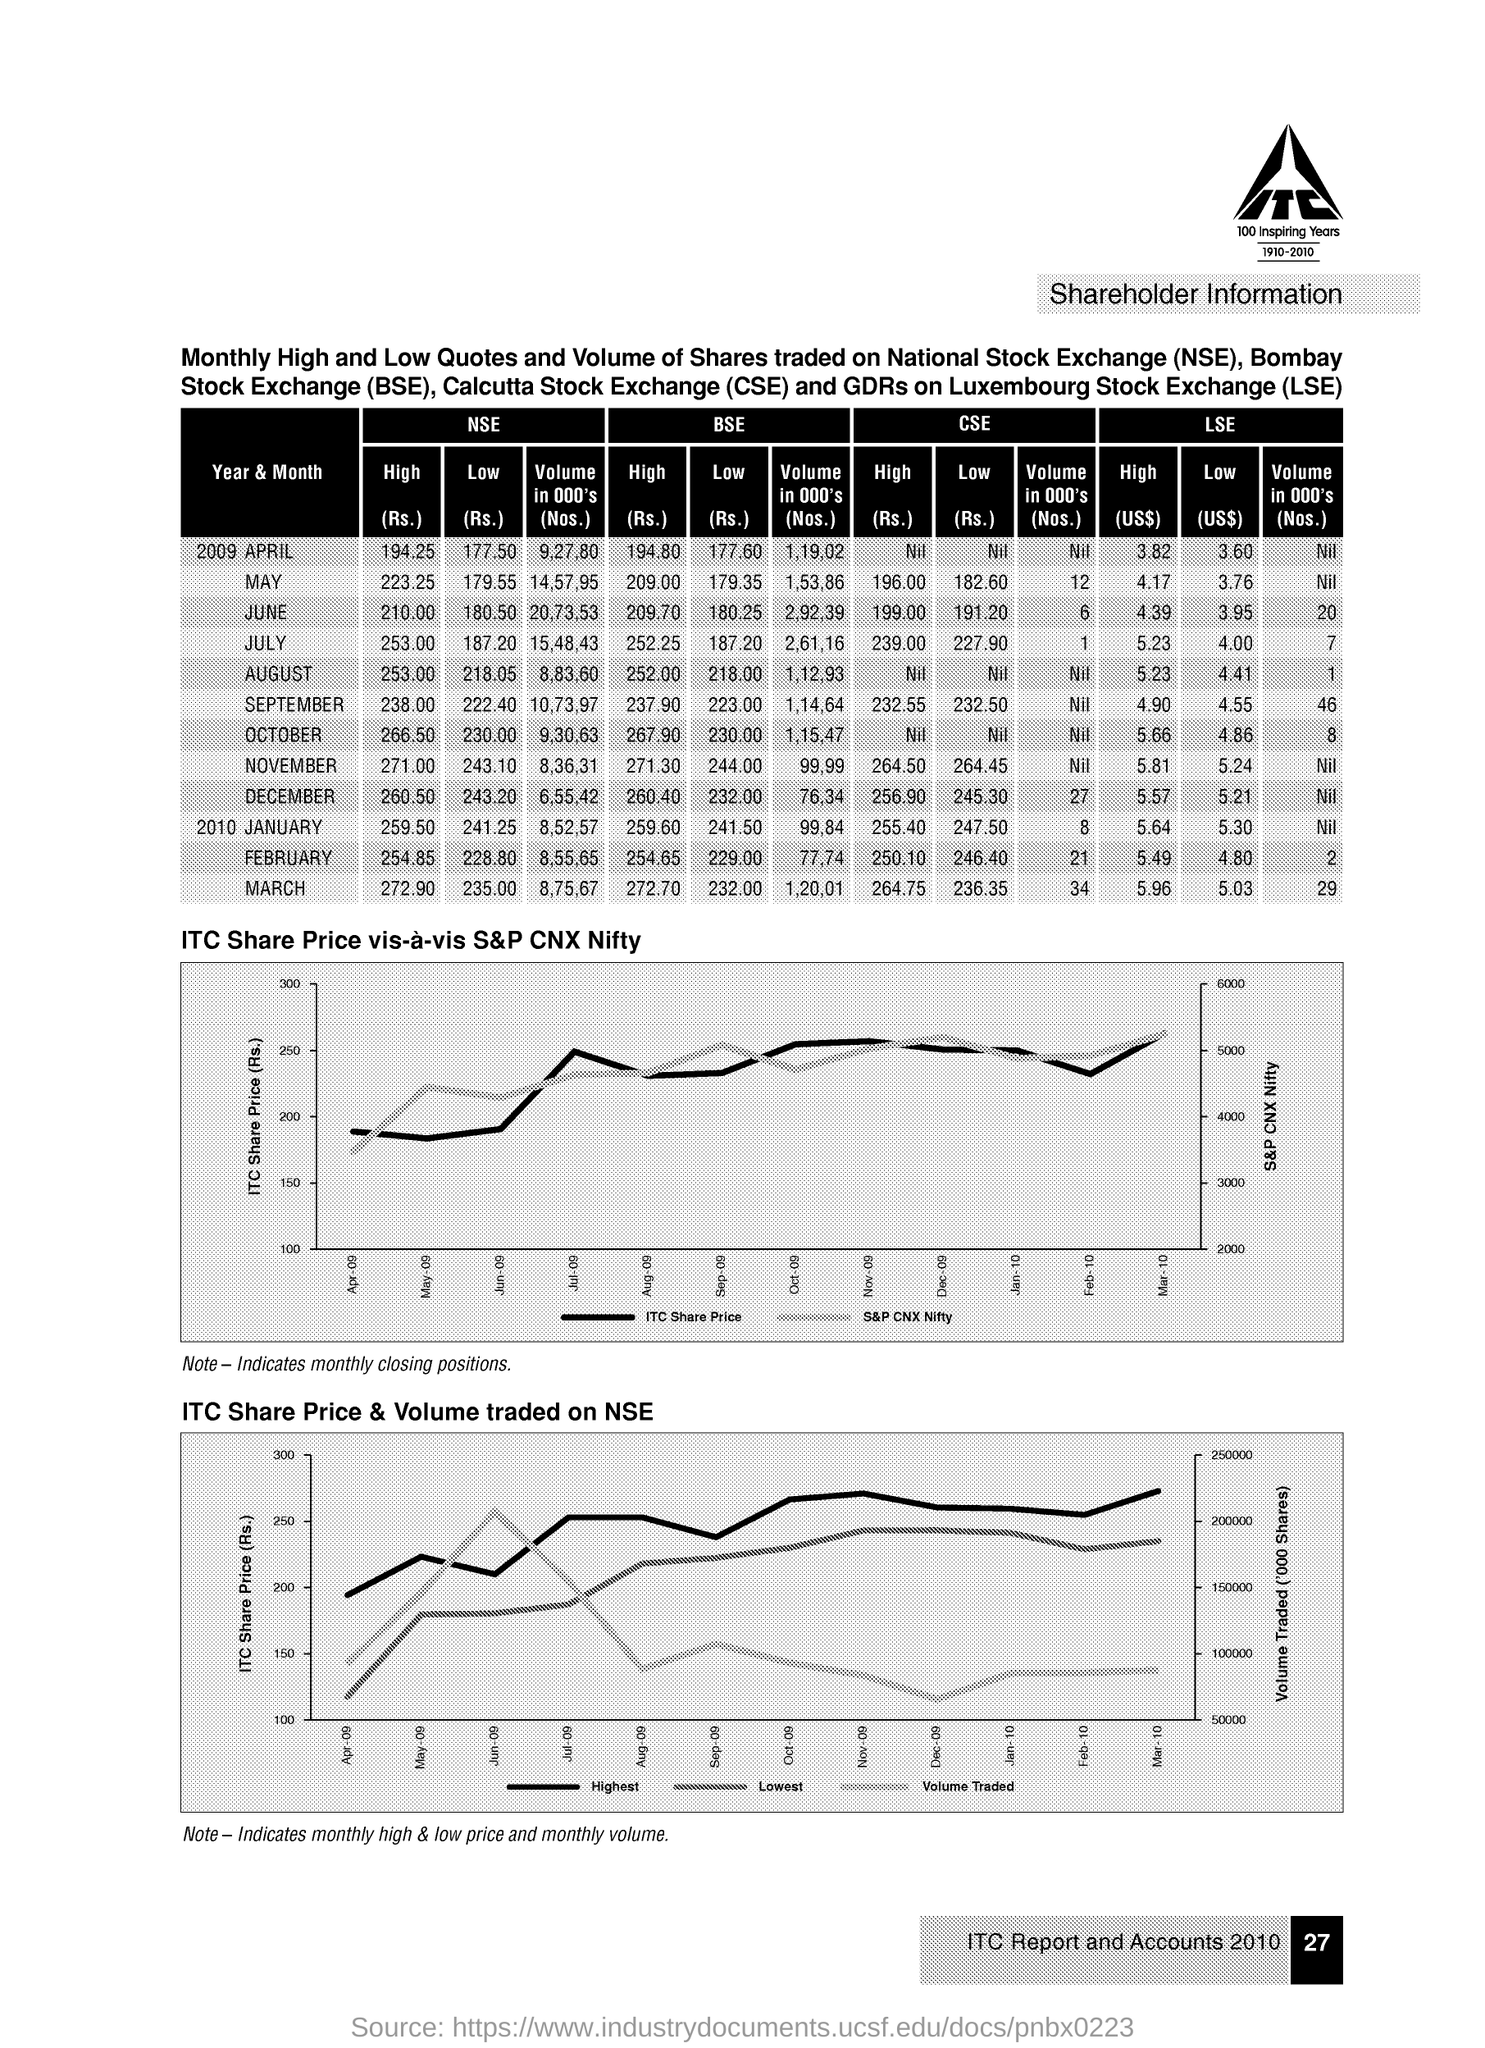What is the full form of nse ?
Your answer should be very brief. National stock exchange. What is the full form of bse ?
Provide a succinct answer. Bombay stock exchange. What is the full form cse ?
Make the answer very short. Calcutta stock exchange. What is the full form of lse?
Your answer should be compact. Luxembourg stock exchange. What is the high price(rs) of nse for the year & month 2009 april
Provide a succinct answer. 194.25. What is the high price (rs) of bse for the year & month 2009 april?
Offer a terse response. 194.80. What is the high price (us$) of lse for the year & month 2009 april?
Make the answer very short. 3.82. What is the volume in 000's(no's) of nse for the year & month 2009 december
Your answer should be compact. 6,55,42. What is the volume in 000's(no's) of lse for the year & month 2009 december
Your response must be concise. Nil. What is the volume in 000's(no's) of bse for the year & month 2009 october
Your response must be concise. 1,15,47. 